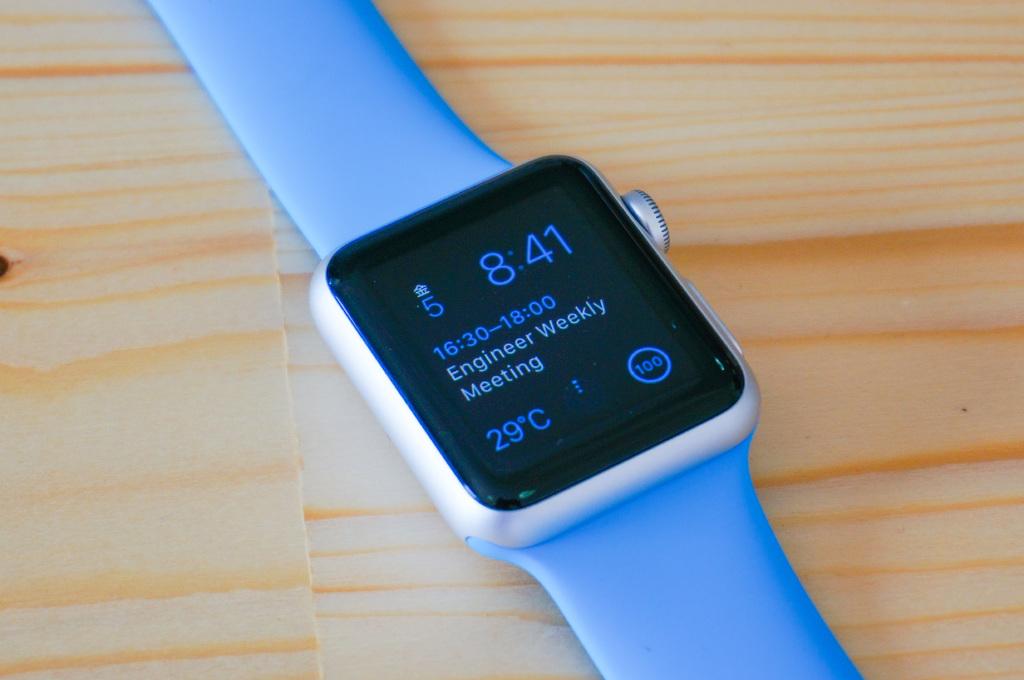What temperature is shown here?
Your response must be concise. 29c. What time is shown here?
Offer a very short reply. 8:41. 